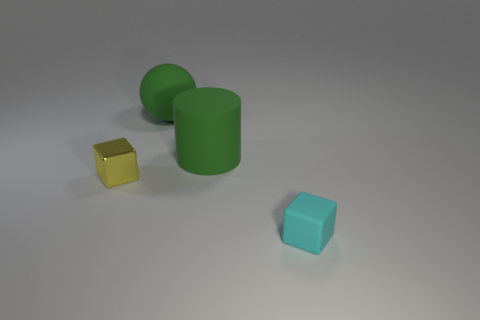How many other things are the same color as the matte cylinder?
Your answer should be compact. 1. Does the large cylinder have the same color as the metal thing?
Your answer should be very brief. No. There is a small object that is in front of the yellow object; is it the same color as the matte cylinder?
Offer a very short reply. No. There is a matte thing in front of the yellow block; does it have the same size as the rubber sphere?
Offer a terse response. No. Is there a shiny thing?
Offer a terse response. Yes. How many objects are either things right of the big green ball or tiny metal blocks?
Provide a short and direct response. 3. Does the matte ball have the same color as the cube to the right of the tiny shiny block?
Your response must be concise. No. Are there any cyan matte blocks of the same size as the green rubber cylinder?
Offer a very short reply. No. What material is the small block to the left of the object that is behind the big rubber cylinder made of?
Your response must be concise. Metal. What number of tiny rubber blocks are the same color as the metallic cube?
Your response must be concise. 0. 